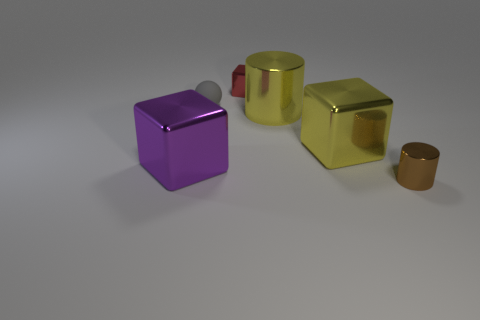Add 1 tiny cubes. How many objects exist? 7 Subtract all cylinders. How many objects are left? 4 Subtract 0 blue cylinders. How many objects are left? 6 Subtract all small gray rubber cubes. Subtract all red metal objects. How many objects are left? 5 Add 2 big cubes. How many big cubes are left? 4 Add 1 purple objects. How many purple objects exist? 2 